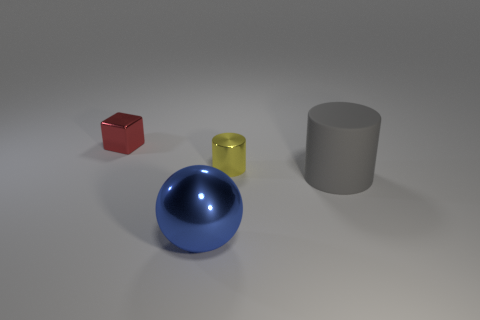There is another object that is the same shape as the gray rubber object; what is its material?
Make the answer very short. Metal. The tiny shiny cube has what color?
Ensure brevity in your answer.  Red. The shiny thing that is in front of the small object that is right of the small cube is what color?
Give a very brief answer. Blue. There is a block; is its color the same as the metal object that is to the right of the large ball?
Your answer should be very brief. No. How many red things are to the left of the tiny object that is to the left of the small thing that is right of the tiny red object?
Your answer should be very brief. 0. Are there any big rubber cylinders behind the shiny cube?
Your response must be concise. No. Are there any other things that are the same color as the metal block?
Keep it short and to the point. No. How many blocks are either matte things or red objects?
Your answer should be compact. 1. How many objects are behind the blue thing and on the right side of the small cube?
Offer a terse response. 2. Are there an equal number of large shiny objects left of the metallic cube and cylinders in front of the large blue shiny object?
Offer a terse response. Yes. 